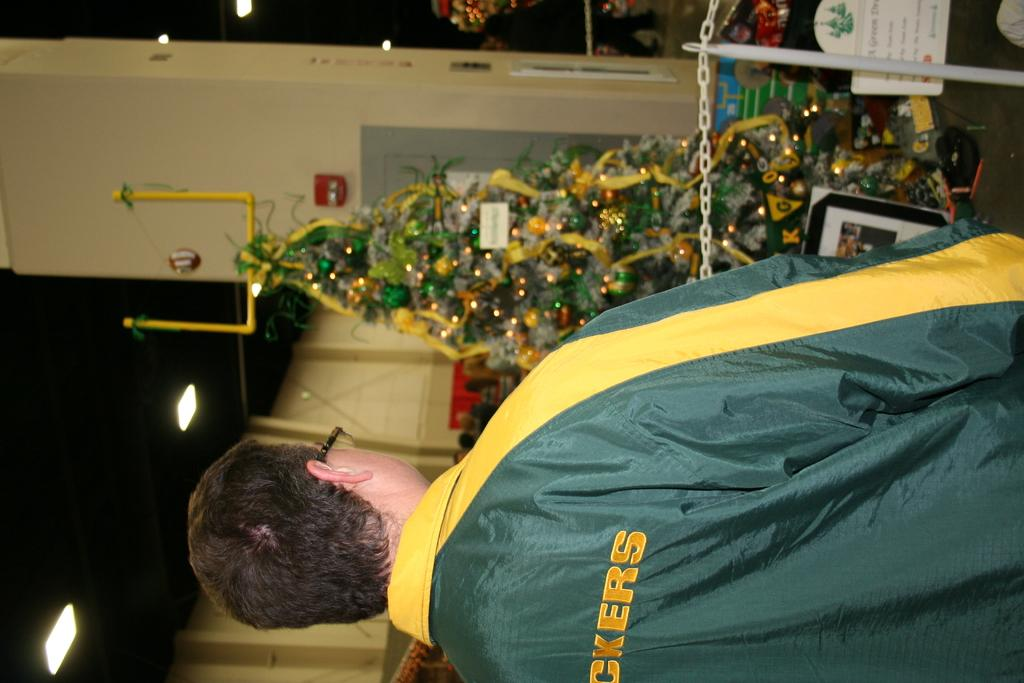Who is present in the image? There is a man in the image. What is the man wearing? The man is wearing a jacket. What can be seen on the walls in the image? There are posters in the image. What is a prominent feature of the room in the image? There is a Christmas tree in the image. What might be used for decoration in the image? Decorations are present in the image. What can be seen illuminating the room in the image? Lights are visible in the image. What type of object can be seen hanging from the ceiling in the image? There is a chain in the image. What type of object can be seen supporting the chain in the image? There is a pole in the image. What type of structure can be seen behind the man in the image? There is a wall in the image. What type of oatmeal is the man eating in the image? There is no oatmeal present in the image; the man is not eating anything. What color are the man's teeth in the image? The image does not show the man's teeth, so we cannot determine their color. 